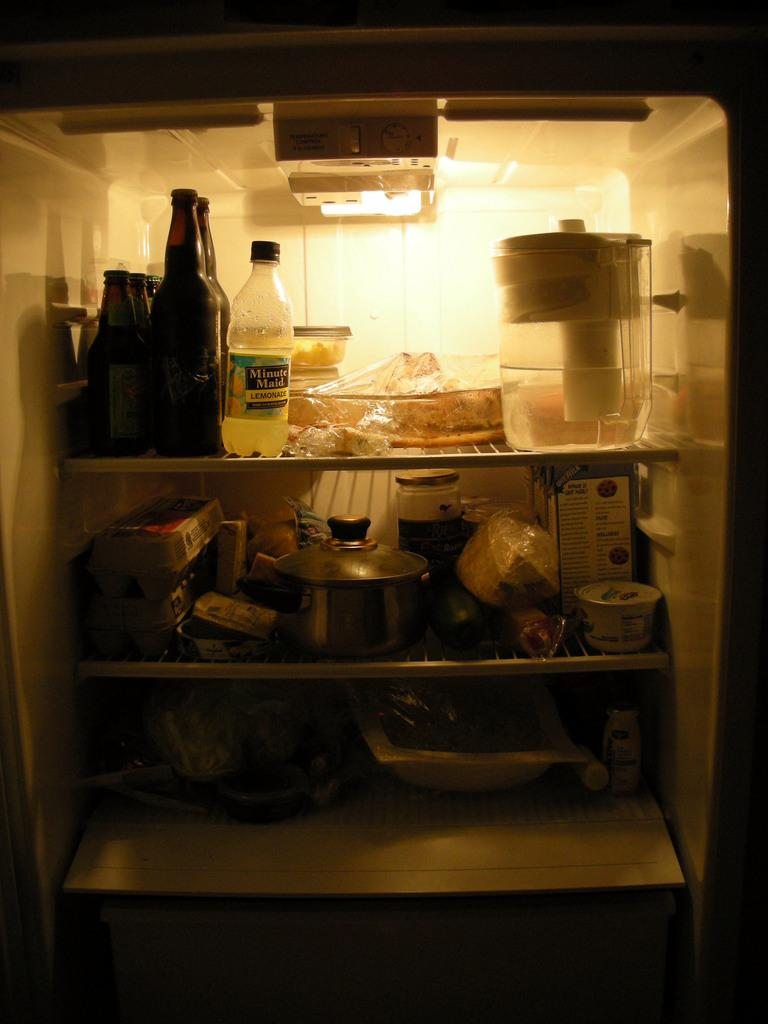<image>
Write a terse but informative summary of the picture. the refrigerator is quite full and has some minute maid lemonade in the top 